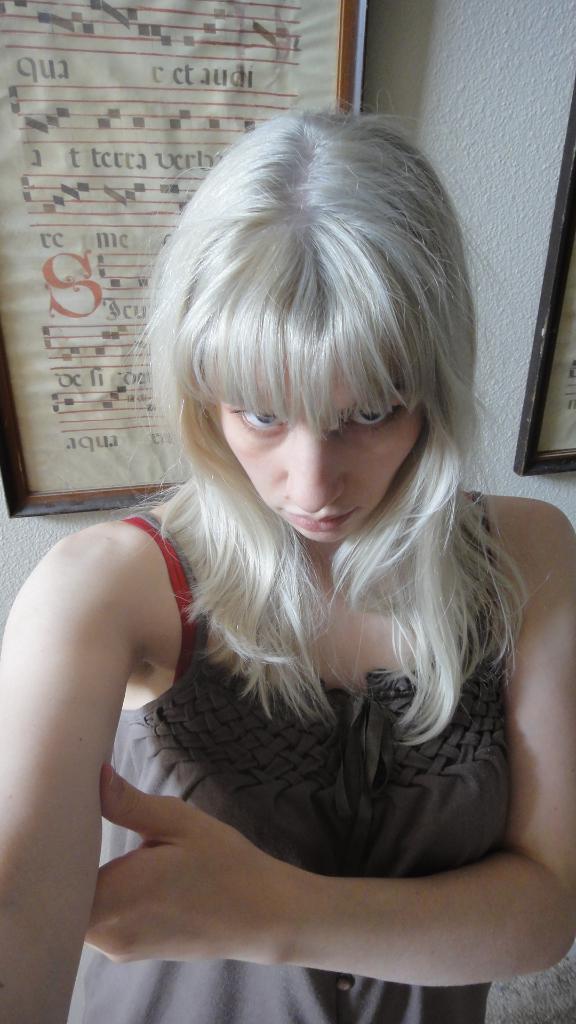In one or two sentences, can you explain what this image depicts? Front portion we can see a woman. Background there is a wall and pictures. Pictures are on the wall. 